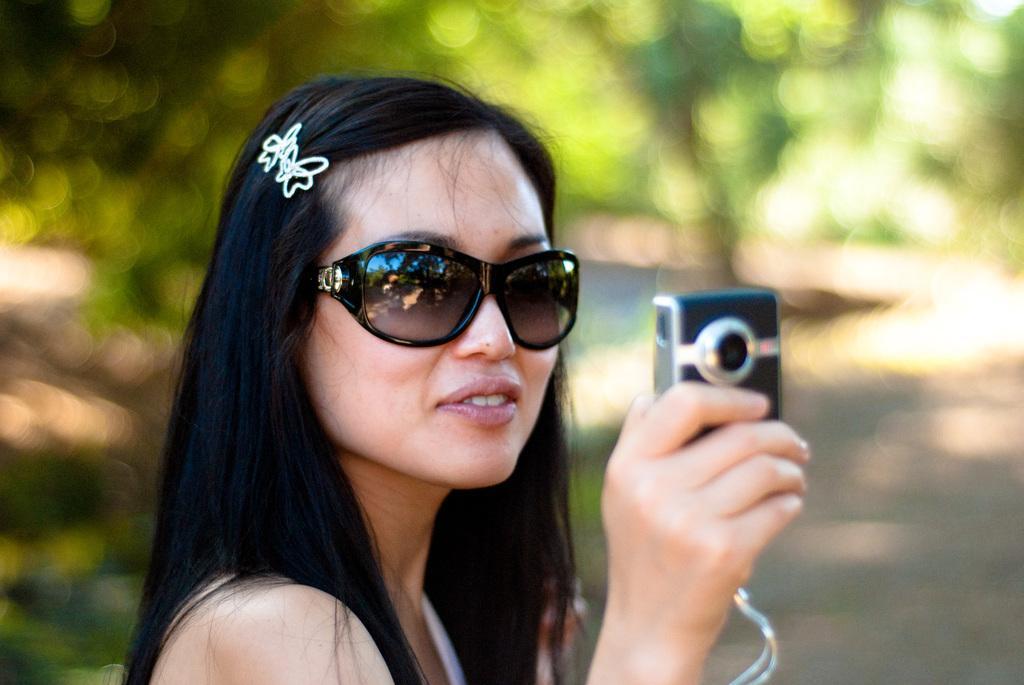Describe this image in one or two sentences. In this picture there is a woman holding a camera. She is wearing a white dress and black spectacles. The background is edited. 